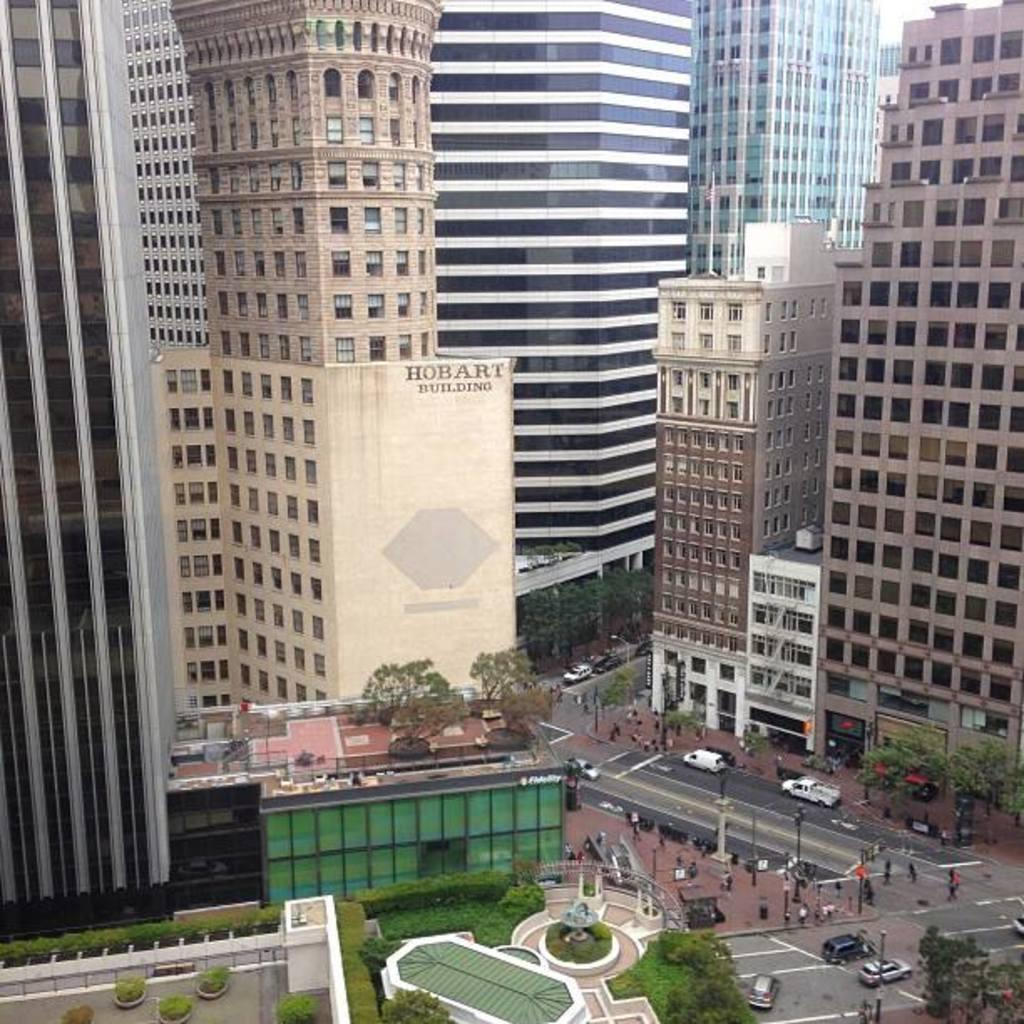What type of structures can be seen in the image? There are buildings in the image. What type of vehicles are present in the image? There are cars in the image. What type of vertical structures can be seen in the image? There are poles in the image. What type of pathway is visible in the image? There is a road in the image. What type of vegetation is present in the image? There are plants and trees in the image. Can you tell me how many buttons are on the pig in the image? There is no pig or button present in the image. What type of creature is shown interacting with the bit in the image? There is no bit present in the image, and therefore no such interaction can be observed. 